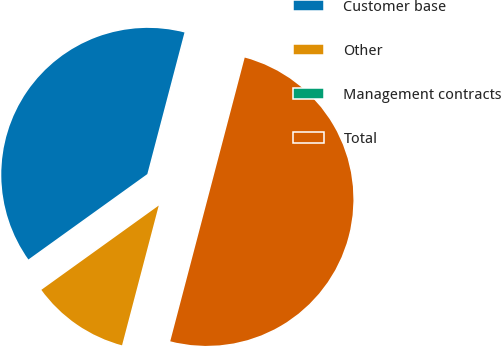<chart> <loc_0><loc_0><loc_500><loc_500><pie_chart><fcel>Customer base<fcel>Other<fcel>Management contracts<fcel>Total<nl><fcel>39.0%<fcel>11.0%<fcel>0.0%<fcel>50.0%<nl></chart> 